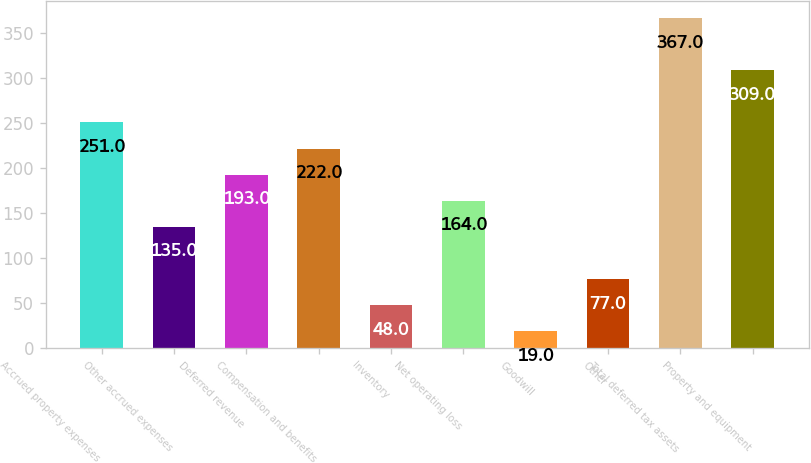Convert chart. <chart><loc_0><loc_0><loc_500><loc_500><bar_chart><fcel>Accrued property expenses<fcel>Other accrued expenses<fcel>Deferred revenue<fcel>Compensation and benefits<fcel>Inventory<fcel>Net operating loss<fcel>Goodwill<fcel>Other<fcel>Total deferred tax assets<fcel>Property and equipment<nl><fcel>251<fcel>135<fcel>193<fcel>222<fcel>48<fcel>164<fcel>19<fcel>77<fcel>367<fcel>309<nl></chart> 